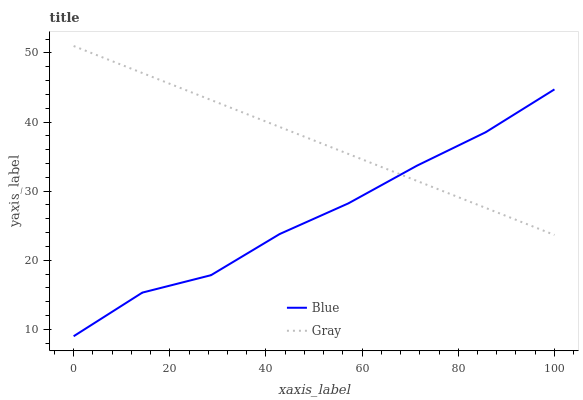Does Blue have the minimum area under the curve?
Answer yes or no. Yes. Does Gray have the maximum area under the curve?
Answer yes or no. Yes. Does Gray have the minimum area under the curve?
Answer yes or no. No. Is Gray the smoothest?
Answer yes or no. Yes. Is Blue the roughest?
Answer yes or no. Yes. Is Gray the roughest?
Answer yes or no. No. Does Gray have the lowest value?
Answer yes or no. No. 